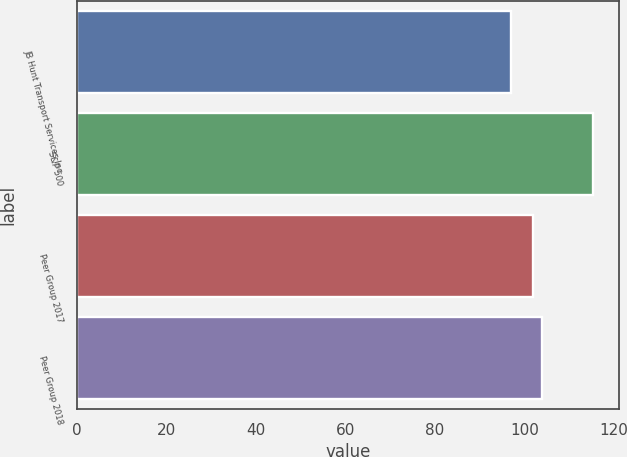<chart> <loc_0><loc_0><loc_500><loc_500><bar_chart><fcel>JB Hunt Transport Services Inc<fcel>S&P 500<fcel>Peer Group 2017<fcel>Peer Group 2018<nl><fcel>96.88<fcel>115.26<fcel>102<fcel>103.84<nl></chart> 